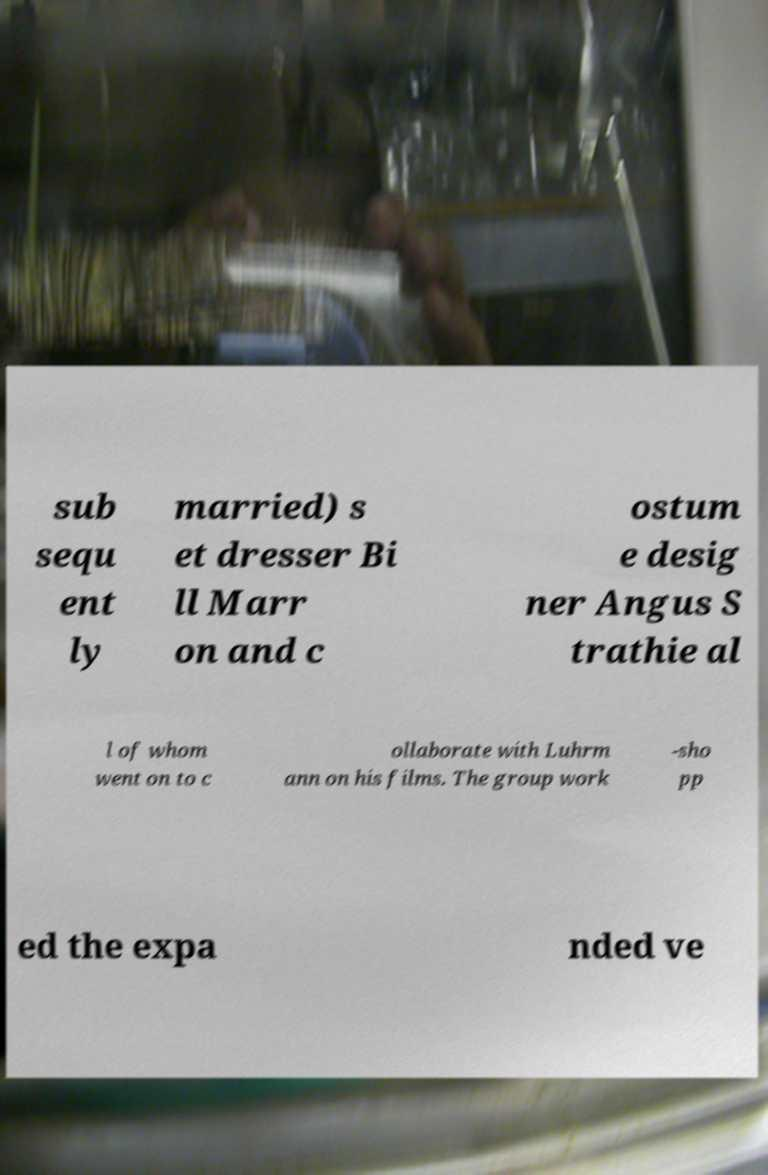Please identify and transcribe the text found in this image. sub sequ ent ly married) s et dresser Bi ll Marr on and c ostum e desig ner Angus S trathie al l of whom went on to c ollaborate with Luhrm ann on his films. The group work -sho pp ed the expa nded ve 